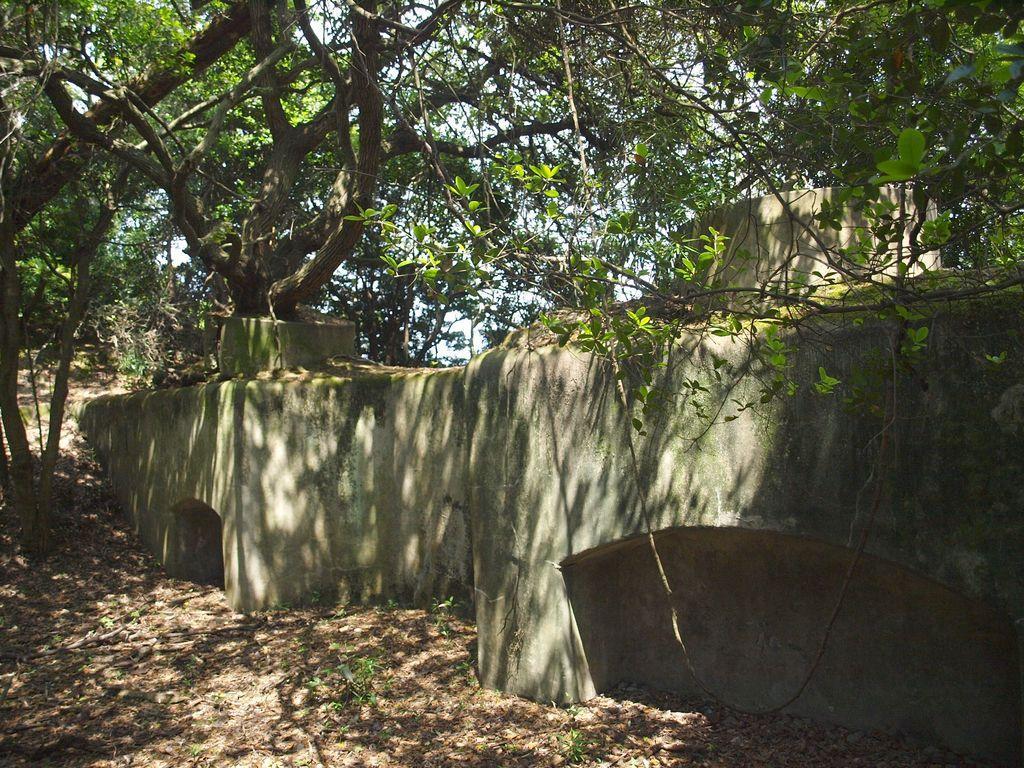How would you summarize this image in a sentence or two? In this image, there is a wall and there are some dried leaves on the ground, there are some green color trees. 